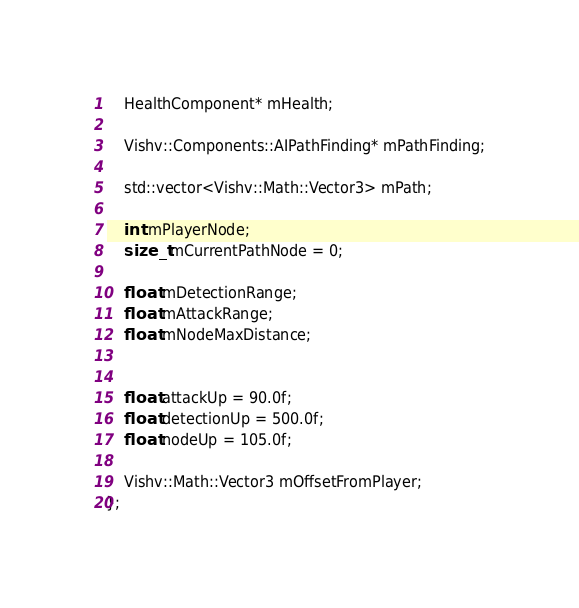<code> <loc_0><loc_0><loc_500><loc_500><_C_>
	HealthComponent* mHealth;

	Vishv::Components::AIPathFinding* mPathFinding;

	std::vector<Vishv::Math::Vector3> mPath;

	int mPlayerNode;
	size_t mCurrentPathNode = 0;

	float mDetectionRange;
	float mAttackRange;
	float mNodeMaxDistance;


	float attackUp = 90.0f;
	float detectionUp = 500.0f;
	float nodeUp = 105.0f;

	Vishv::Math::Vector3 mOffsetFromPlayer;
};


</code> 